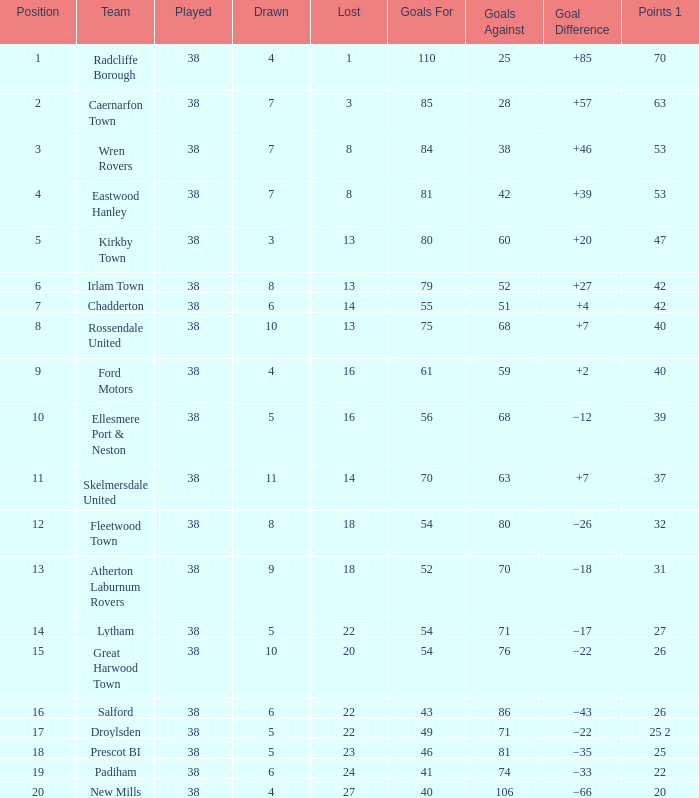Which lost holds a place exceeding 5, and points 1 of 37, and under 63 goals against? None. 